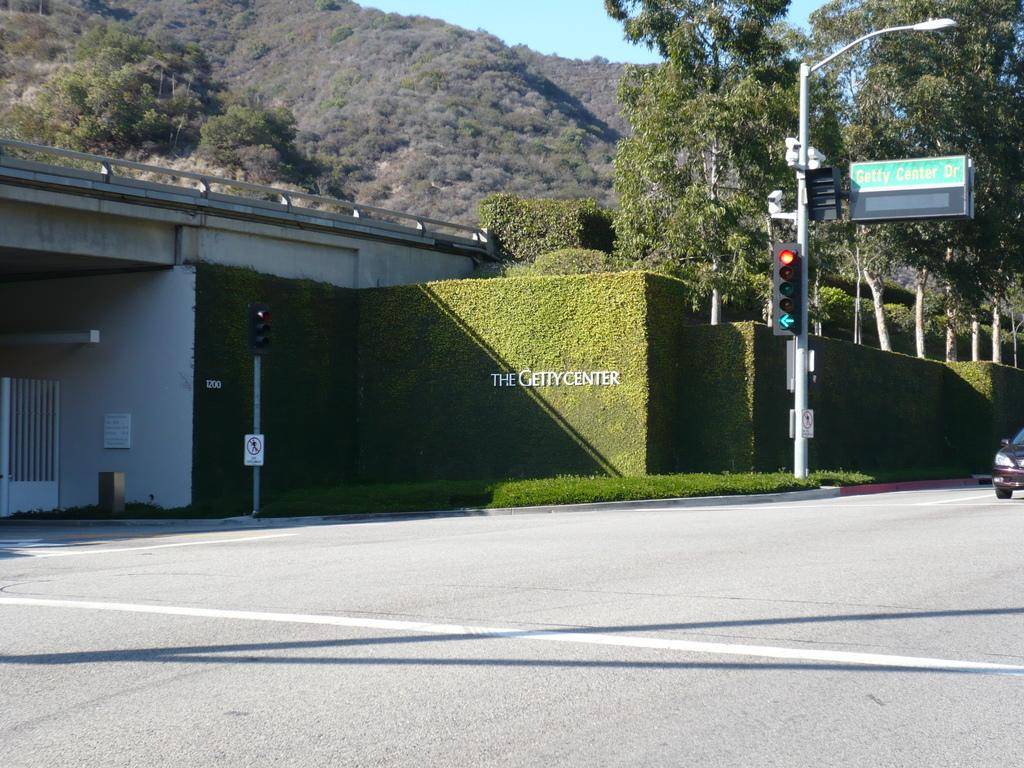What type of natural elements can be seen in the image? There are trees and mountains in the image. What man-made structures are present in the image? There are traffic signals, a pole, sign boards, a vehicle, and a bridge in the image. What is the color of the sky in the image? The sky is blue in the image. What type of distribution system is visible in the image? There is no distribution system present in the image. Can you see a drum being played in the image? There is no drum or any musical instrument being played in the image. 